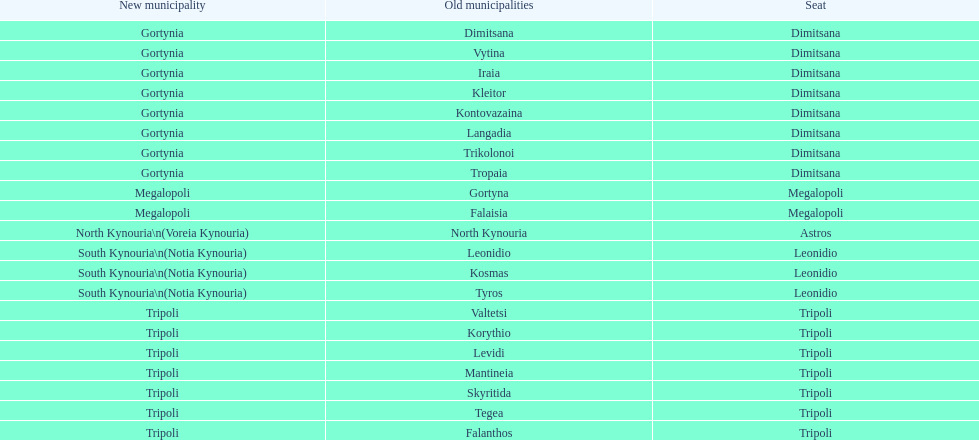What does the new municipal region of tyros consist of? South Kynouria. 